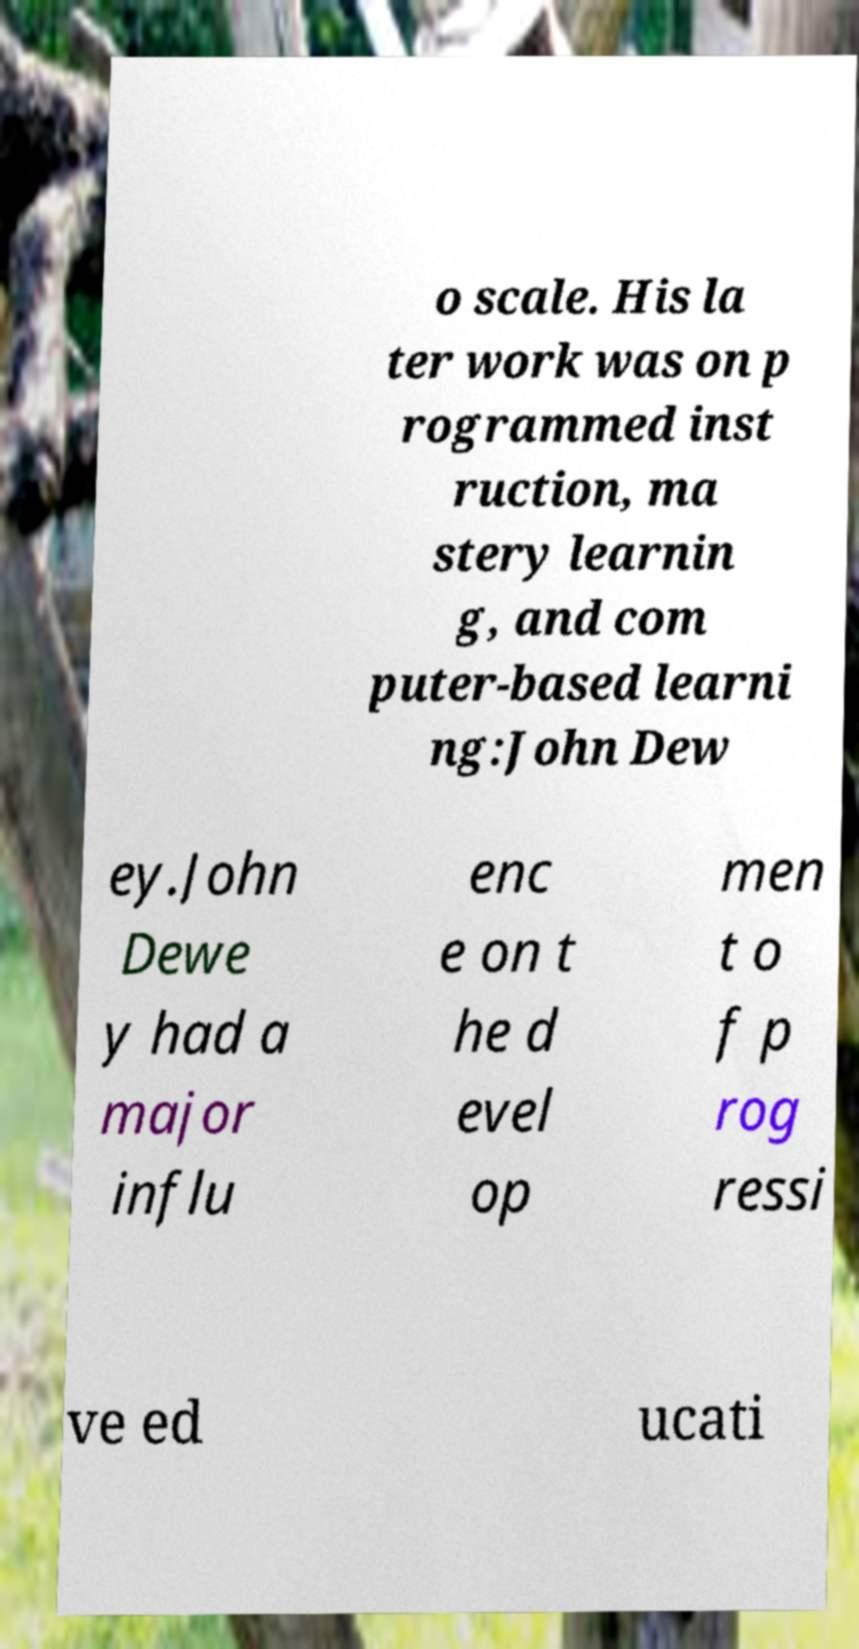There's text embedded in this image that I need extracted. Can you transcribe it verbatim? o scale. His la ter work was on p rogrammed inst ruction, ma stery learnin g, and com puter-based learni ng:John Dew ey.John Dewe y had a major influ enc e on t he d evel op men t o f p rog ressi ve ed ucati 